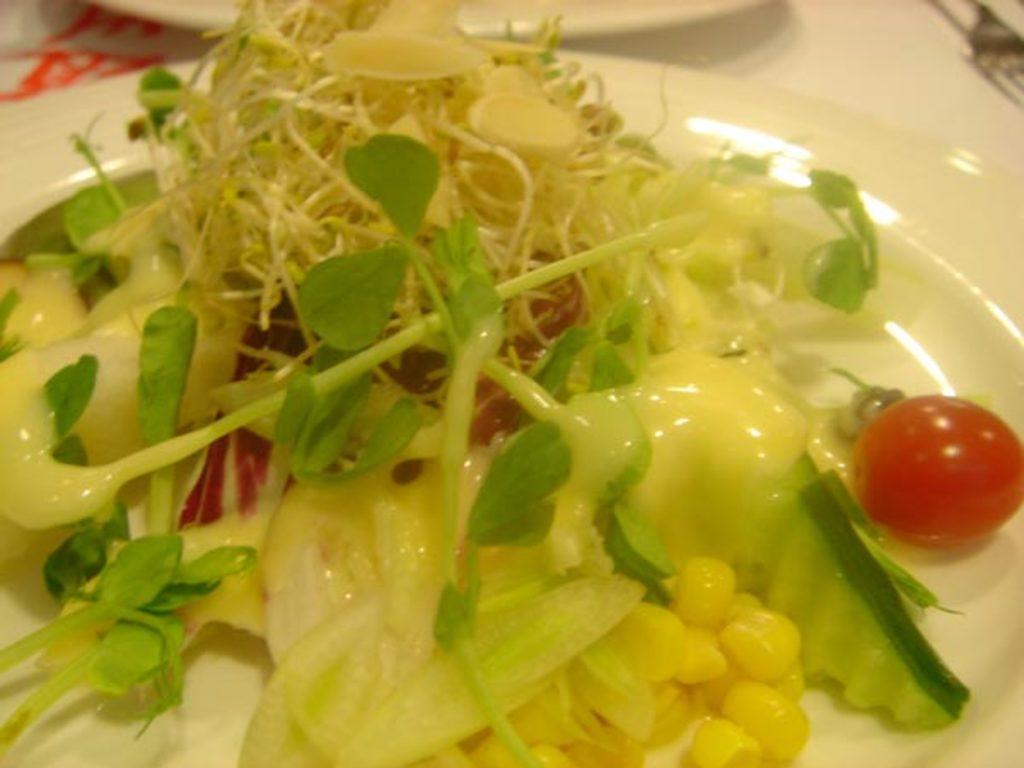Please provide a concise description of this image. In this picture I can see there is a plate of food here, it has some corn, leafy vegetables and cherry. There are forks and there is another plate on the table. 